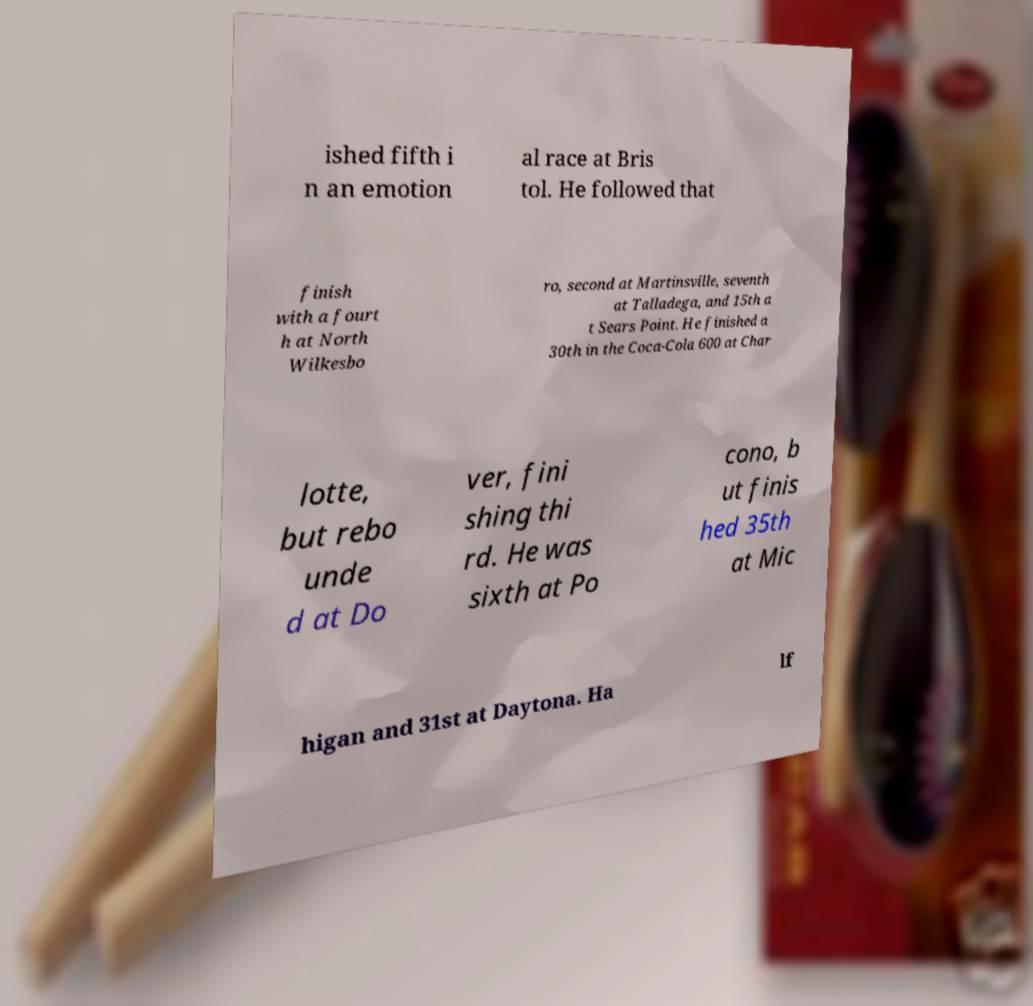There's text embedded in this image that I need extracted. Can you transcribe it verbatim? ished fifth i n an emotion al race at Bris tol. He followed that finish with a fourt h at North Wilkesbo ro, second at Martinsville, seventh at Talladega, and 15th a t Sears Point. He finished a 30th in the Coca-Cola 600 at Char lotte, but rebo unde d at Do ver, fini shing thi rd. He was sixth at Po cono, b ut finis hed 35th at Mic higan and 31st at Daytona. Ha lf 